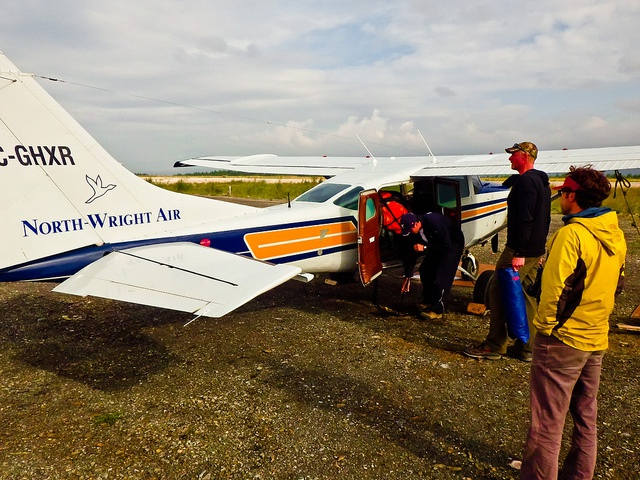Describe the objects in this image and their specific colors. I can see airplane in darkgray, ivory, black, and navy tones, people in darkgray, black, orange, maroon, and olive tones, people in darkgray, black, maroon, olive, and brown tones, people in darkgray, black, maroon, and olive tones, and people in darkgray, red, black, and maroon tones in this image. 